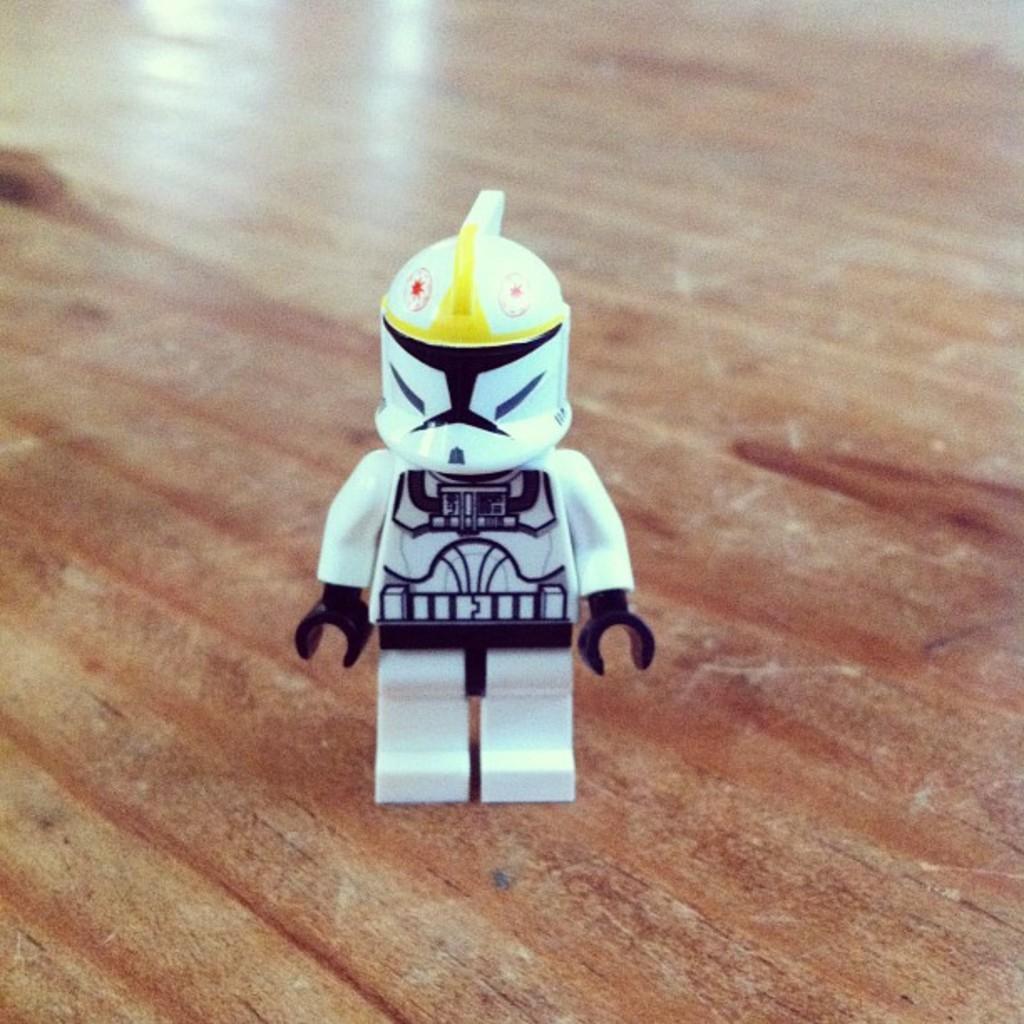Please provide a concise description of this image. In this image we can see a toy which is placed on the wooden surface. 